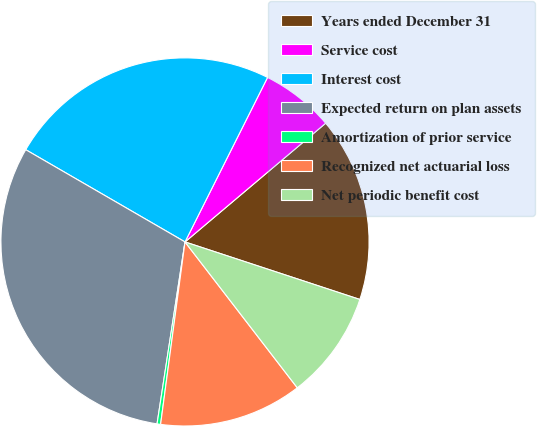<chart> <loc_0><loc_0><loc_500><loc_500><pie_chart><fcel>Years ended December 31<fcel>Service cost<fcel>Interest cost<fcel>Expected return on plan assets<fcel>Amortization of prior service<fcel>Recognized net actuarial loss<fcel>Net periodic benefit cost<nl><fcel>16.22%<fcel>6.44%<fcel>24.05%<fcel>30.93%<fcel>0.31%<fcel>12.56%<fcel>9.5%<nl></chart> 